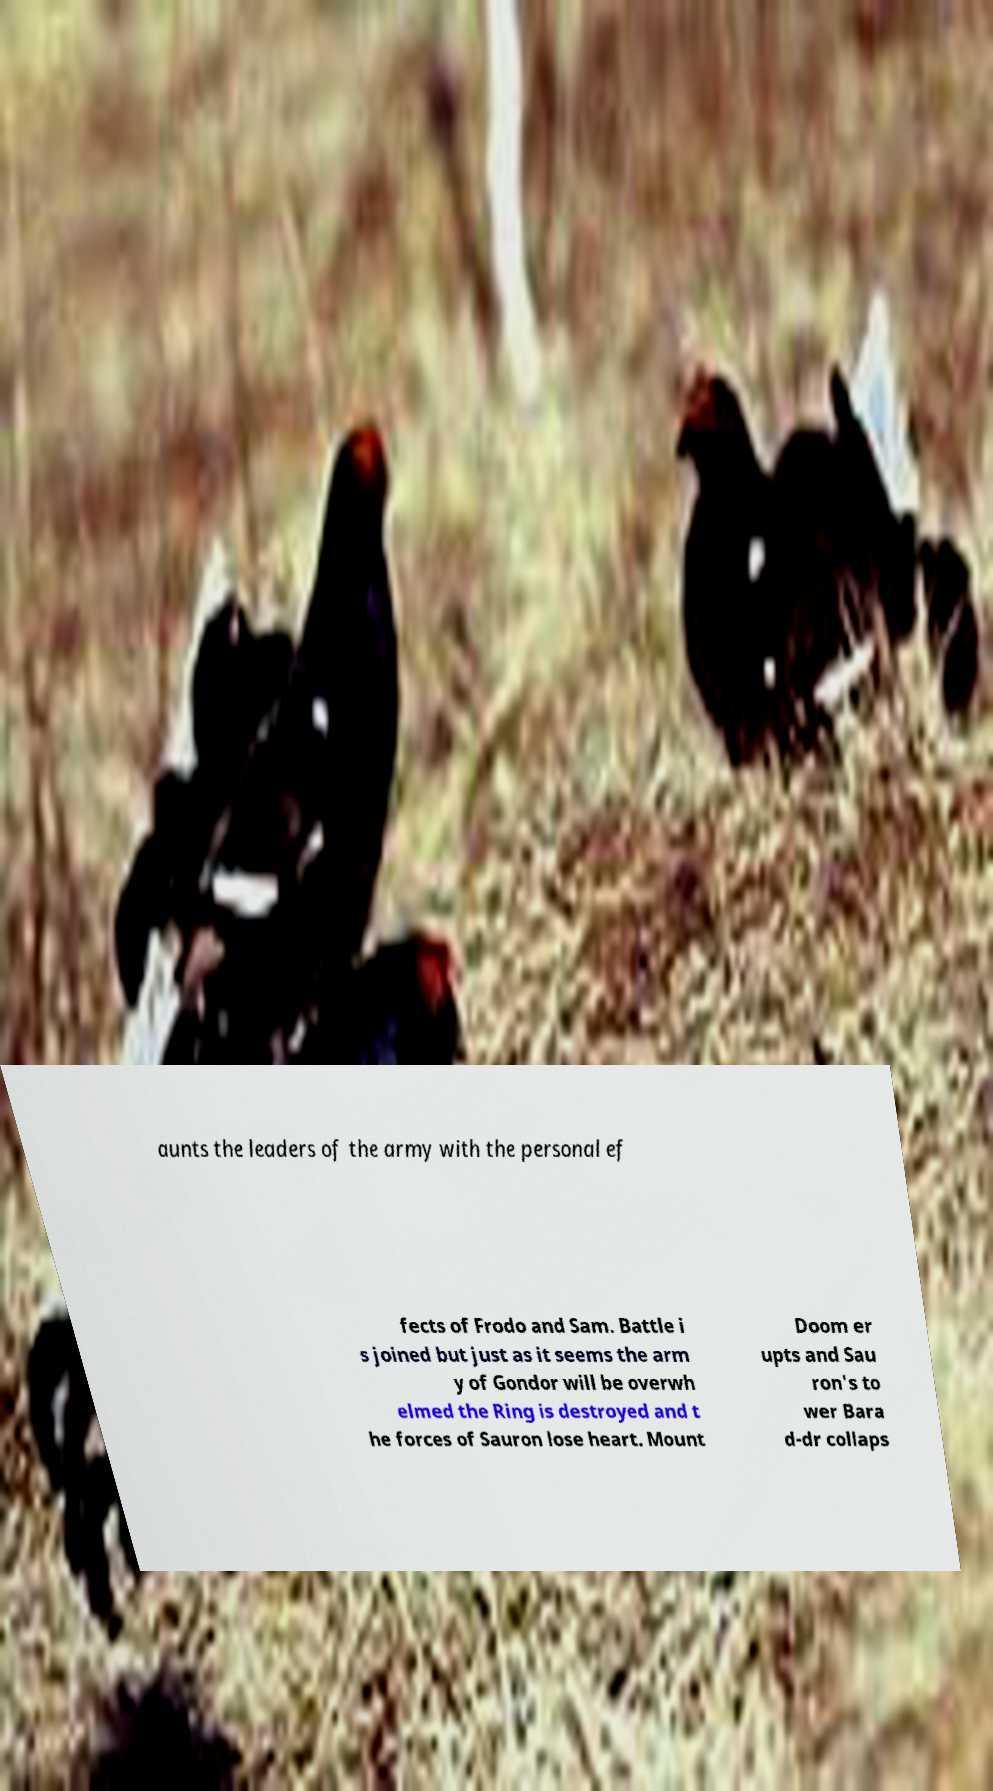There's text embedded in this image that I need extracted. Can you transcribe it verbatim? aunts the leaders of the army with the personal ef fects of Frodo and Sam. Battle i s joined but just as it seems the arm y of Gondor will be overwh elmed the Ring is destroyed and t he forces of Sauron lose heart. Mount Doom er upts and Sau ron's to wer Bara d-dr collaps 